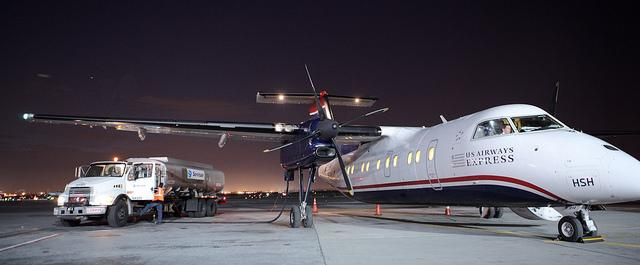What color is the underbelly of this private jet? black 